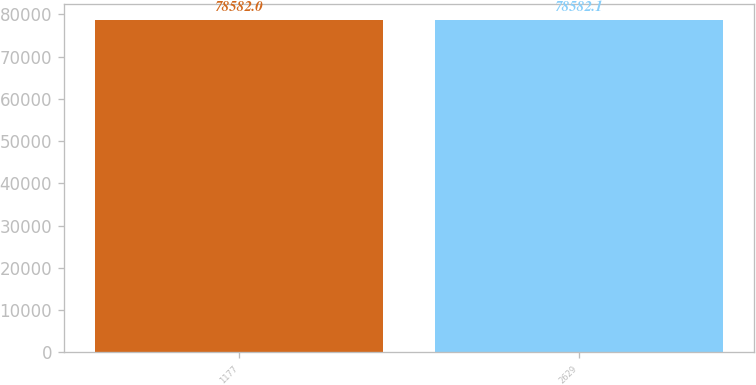Convert chart to OTSL. <chart><loc_0><loc_0><loc_500><loc_500><bar_chart><fcel>1177<fcel>2629<nl><fcel>78582<fcel>78582.1<nl></chart> 